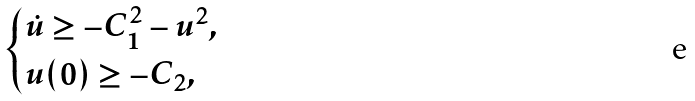<formula> <loc_0><loc_0><loc_500><loc_500>\begin{cases} \dot { u } \geq - C _ { 1 } ^ { 2 } - u ^ { 2 } , & \\ u ( 0 ) \geq - C _ { 2 } , \end{cases}</formula> 